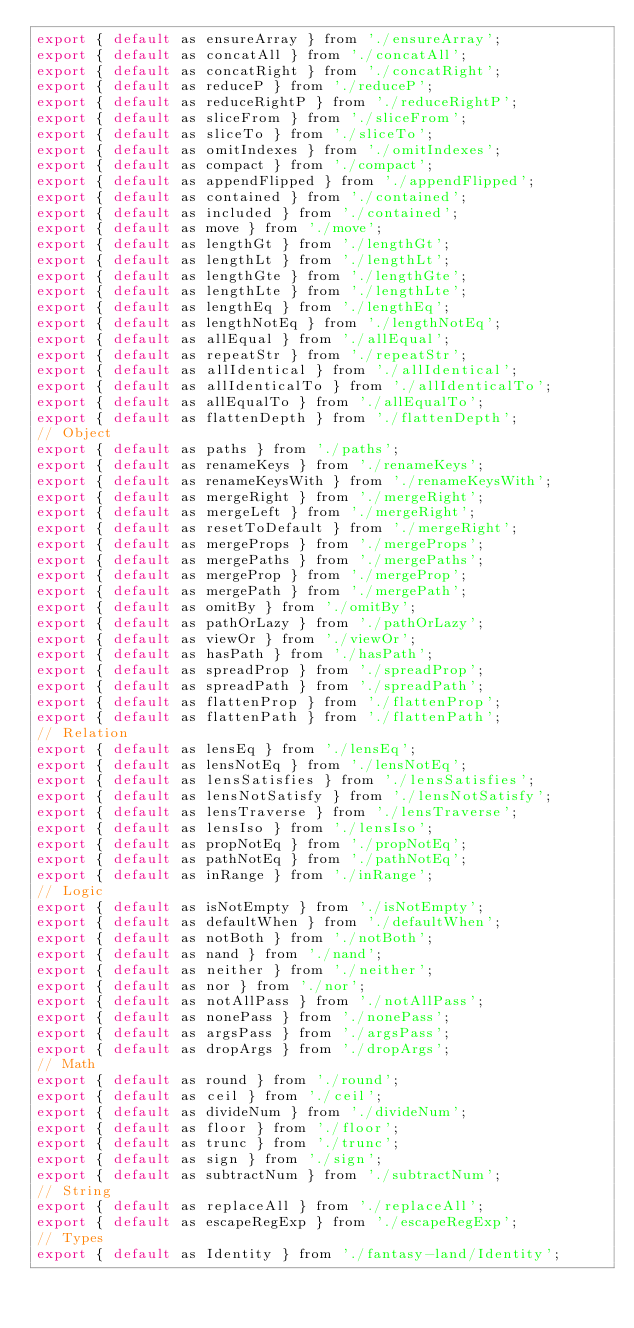<code> <loc_0><loc_0><loc_500><loc_500><_JavaScript_>export { default as ensureArray } from './ensureArray';
export { default as concatAll } from './concatAll';
export { default as concatRight } from './concatRight';
export { default as reduceP } from './reduceP';
export { default as reduceRightP } from './reduceRightP';
export { default as sliceFrom } from './sliceFrom';
export { default as sliceTo } from './sliceTo';
export { default as omitIndexes } from './omitIndexes';
export { default as compact } from './compact';
export { default as appendFlipped } from './appendFlipped';
export { default as contained } from './contained';
export { default as included } from './contained';
export { default as move } from './move';
export { default as lengthGt } from './lengthGt';
export { default as lengthLt } from './lengthLt';
export { default as lengthGte } from './lengthGte';
export { default as lengthLte } from './lengthLte';
export { default as lengthEq } from './lengthEq';
export { default as lengthNotEq } from './lengthNotEq';
export { default as allEqual } from './allEqual';
export { default as repeatStr } from './repeatStr';
export { default as allIdentical } from './allIdentical';
export { default as allIdenticalTo } from './allIdenticalTo';
export { default as allEqualTo } from './allEqualTo';
export { default as flattenDepth } from './flattenDepth';
// Object
export { default as paths } from './paths';
export { default as renameKeys } from './renameKeys';
export { default as renameKeysWith } from './renameKeysWith';
export { default as mergeRight } from './mergeRight';
export { default as mergeLeft } from './mergeRight';
export { default as resetToDefault } from './mergeRight';
export { default as mergeProps } from './mergeProps';
export { default as mergePaths } from './mergePaths';
export { default as mergeProp } from './mergeProp';
export { default as mergePath } from './mergePath';
export { default as omitBy } from './omitBy';
export { default as pathOrLazy } from './pathOrLazy';
export { default as viewOr } from './viewOr';
export { default as hasPath } from './hasPath';
export { default as spreadProp } from './spreadProp';
export { default as spreadPath } from './spreadPath';
export { default as flattenProp } from './flattenProp';
export { default as flattenPath } from './flattenPath';
// Relation
export { default as lensEq } from './lensEq';
export { default as lensNotEq } from './lensNotEq';
export { default as lensSatisfies } from './lensSatisfies';
export { default as lensNotSatisfy } from './lensNotSatisfy';
export { default as lensTraverse } from './lensTraverse';
export { default as lensIso } from './lensIso';
export { default as propNotEq } from './propNotEq';
export { default as pathNotEq } from './pathNotEq';
export { default as inRange } from './inRange';
// Logic
export { default as isNotEmpty } from './isNotEmpty';
export { default as defaultWhen } from './defaultWhen';
export { default as notBoth } from './notBoth';
export { default as nand } from './nand';
export { default as neither } from './neither';
export { default as nor } from './nor';
export { default as notAllPass } from './notAllPass';
export { default as nonePass } from './nonePass';
export { default as argsPass } from './argsPass';
export { default as dropArgs } from './dropArgs';
// Math
export { default as round } from './round';
export { default as ceil } from './ceil';
export { default as divideNum } from './divideNum';
export { default as floor } from './floor';
export { default as trunc } from './trunc';
export { default as sign } from './sign';
export { default as subtractNum } from './subtractNum';
// String
export { default as replaceAll } from './replaceAll';
export { default as escapeRegExp } from './escapeRegExp';
// Types
export { default as Identity } from './fantasy-land/Identity';
</code> 